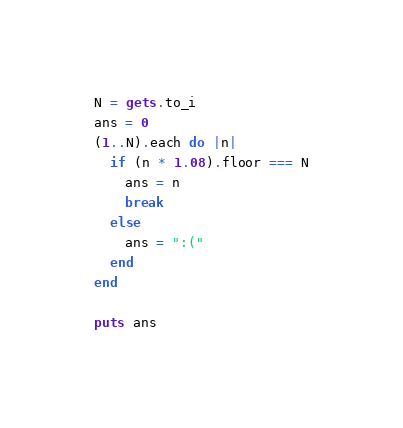<code> <loc_0><loc_0><loc_500><loc_500><_Ruby_>N = gets.to_i
ans = 0
(1..N).each do |n|
  if (n * 1.08).floor === N
    ans = n
    break
  else
    ans = ":("
  end
end

puts ans</code> 